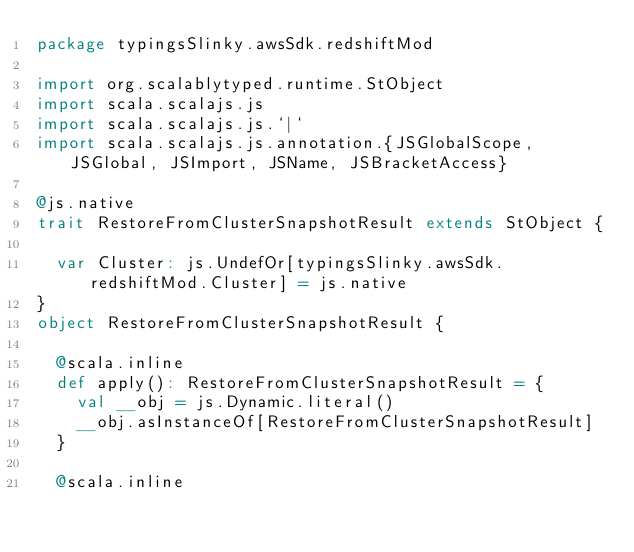<code> <loc_0><loc_0><loc_500><loc_500><_Scala_>package typingsSlinky.awsSdk.redshiftMod

import org.scalablytyped.runtime.StObject
import scala.scalajs.js
import scala.scalajs.js.`|`
import scala.scalajs.js.annotation.{JSGlobalScope, JSGlobal, JSImport, JSName, JSBracketAccess}

@js.native
trait RestoreFromClusterSnapshotResult extends StObject {
  
  var Cluster: js.UndefOr[typingsSlinky.awsSdk.redshiftMod.Cluster] = js.native
}
object RestoreFromClusterSnapshotResult {
  
  @scala.inline
  def apply(): RestoreFromClusterSnapshotResult = {
    val __obj = js.Dynamic.literal()
    __obj.asInstanceOf[RestoreFromClusterSnapshotResult]
  }
  
  @scala.inline</code> 